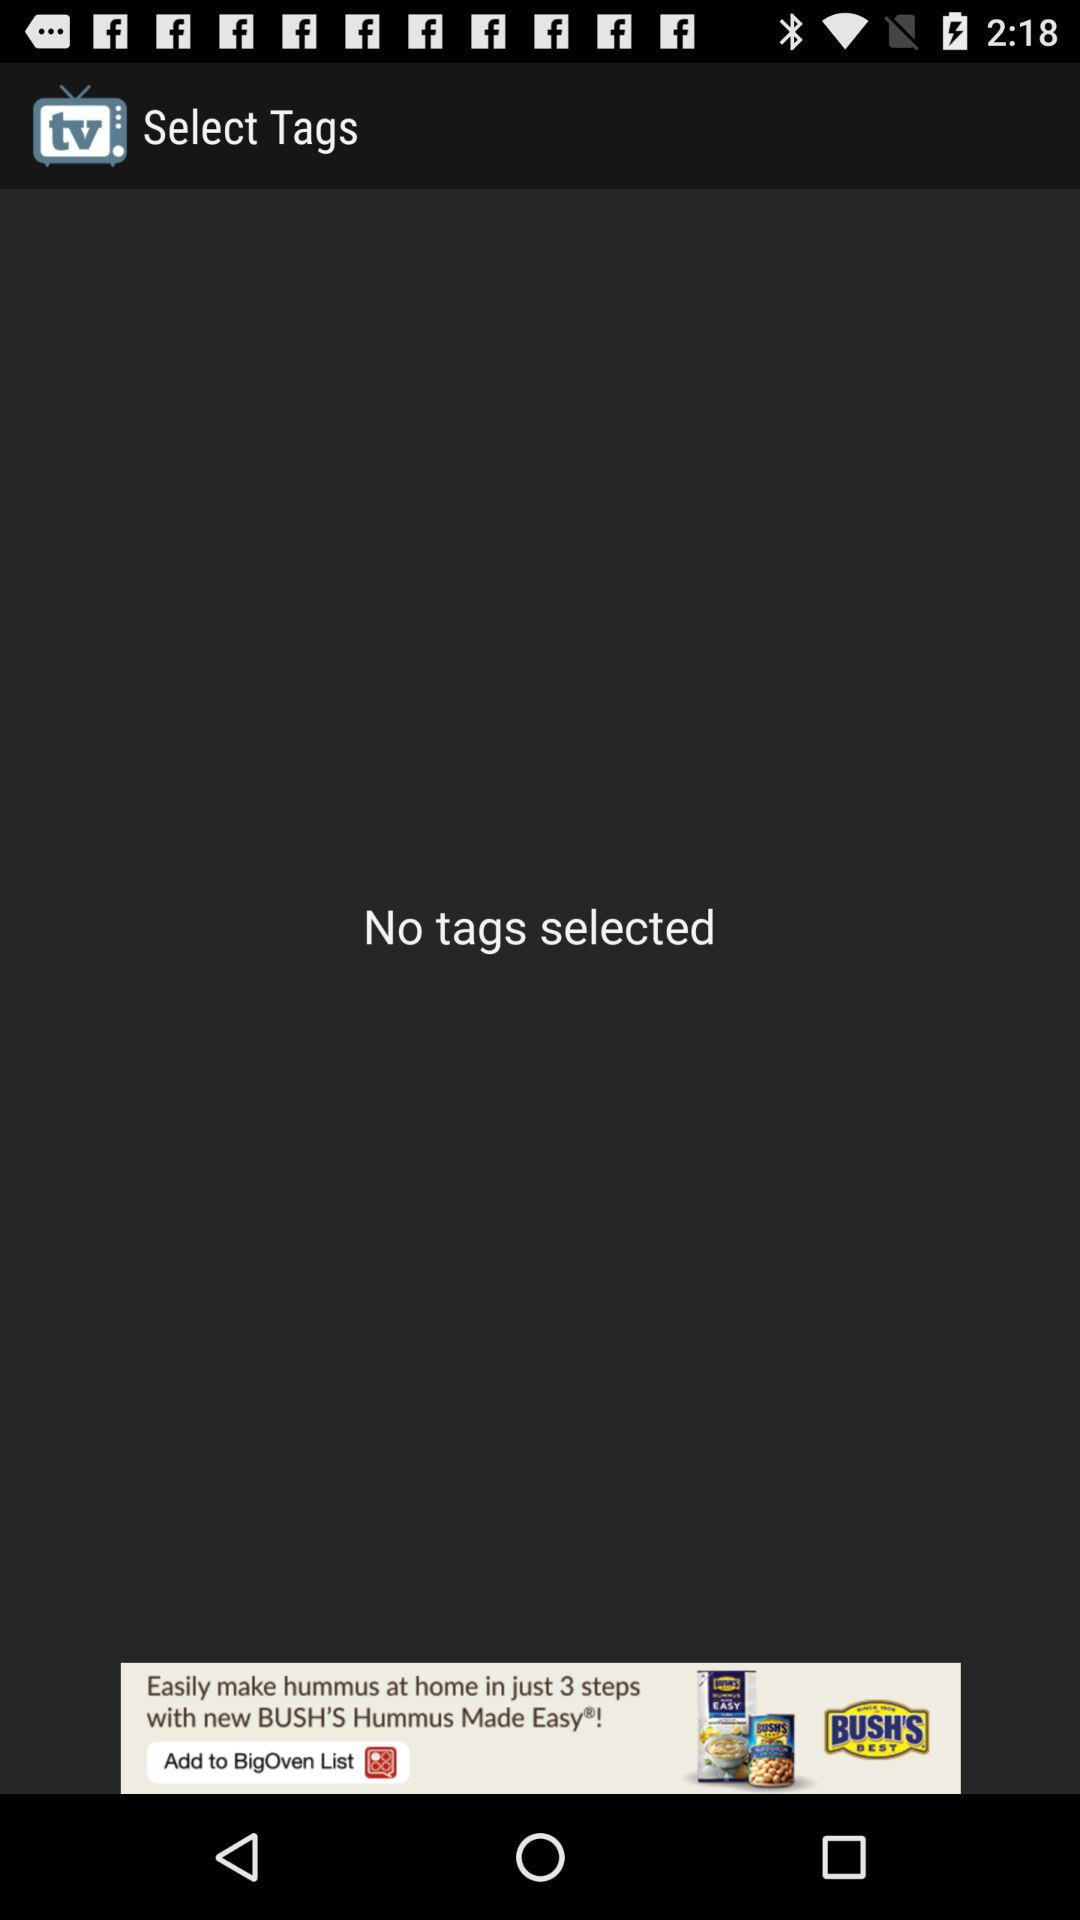Are there any tags selected? There are no tags selected. 